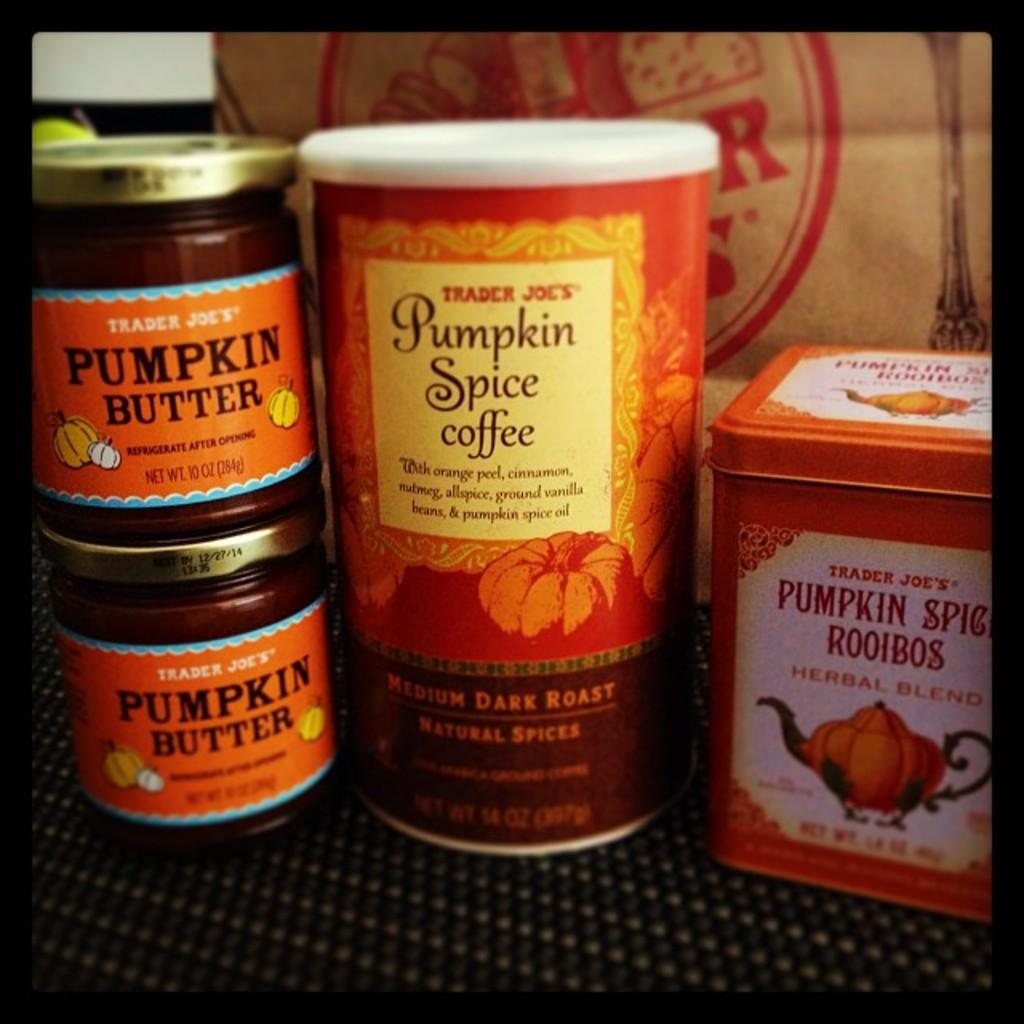Provide a one-sentence caption for the provided image. Several items involving pumpkin spice sit stacked on a counter. 